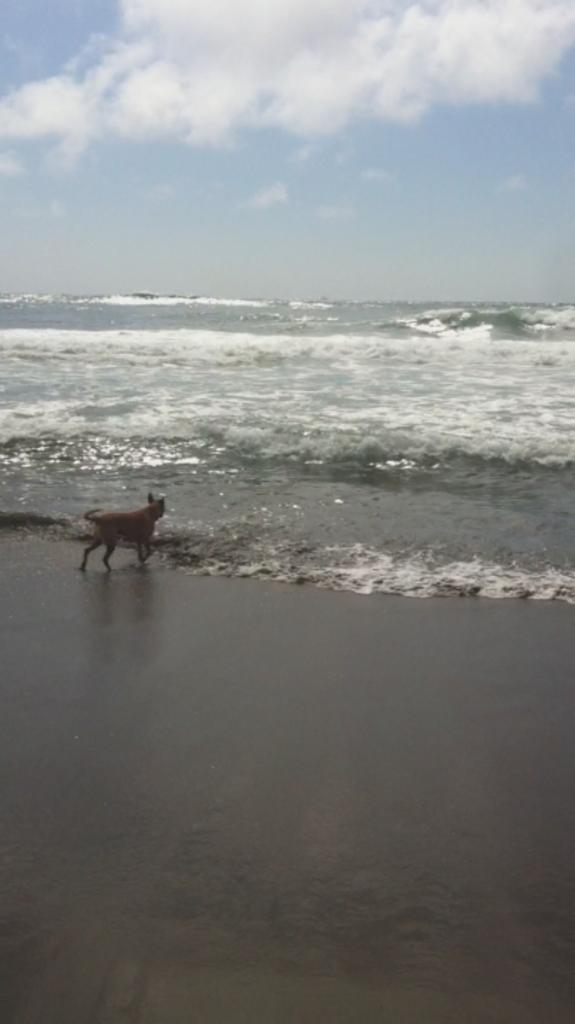What type of animal can be seen in the image? There is an animal in the image, but its specific type is not mentioned in the facts. Where is the animal located in the image? The animal is standing on the seashore. What natural feature is visible in the background of the image? The sea is visible in the image. What else can be seen in the sky in the image? The sky is visible in the image, and there are clouds present. What type of sheet is covering the animal's collar in the image? There is no sheet or collar mentioned in the image, as the facts only describe the animal, its location, and the visible natural features. 